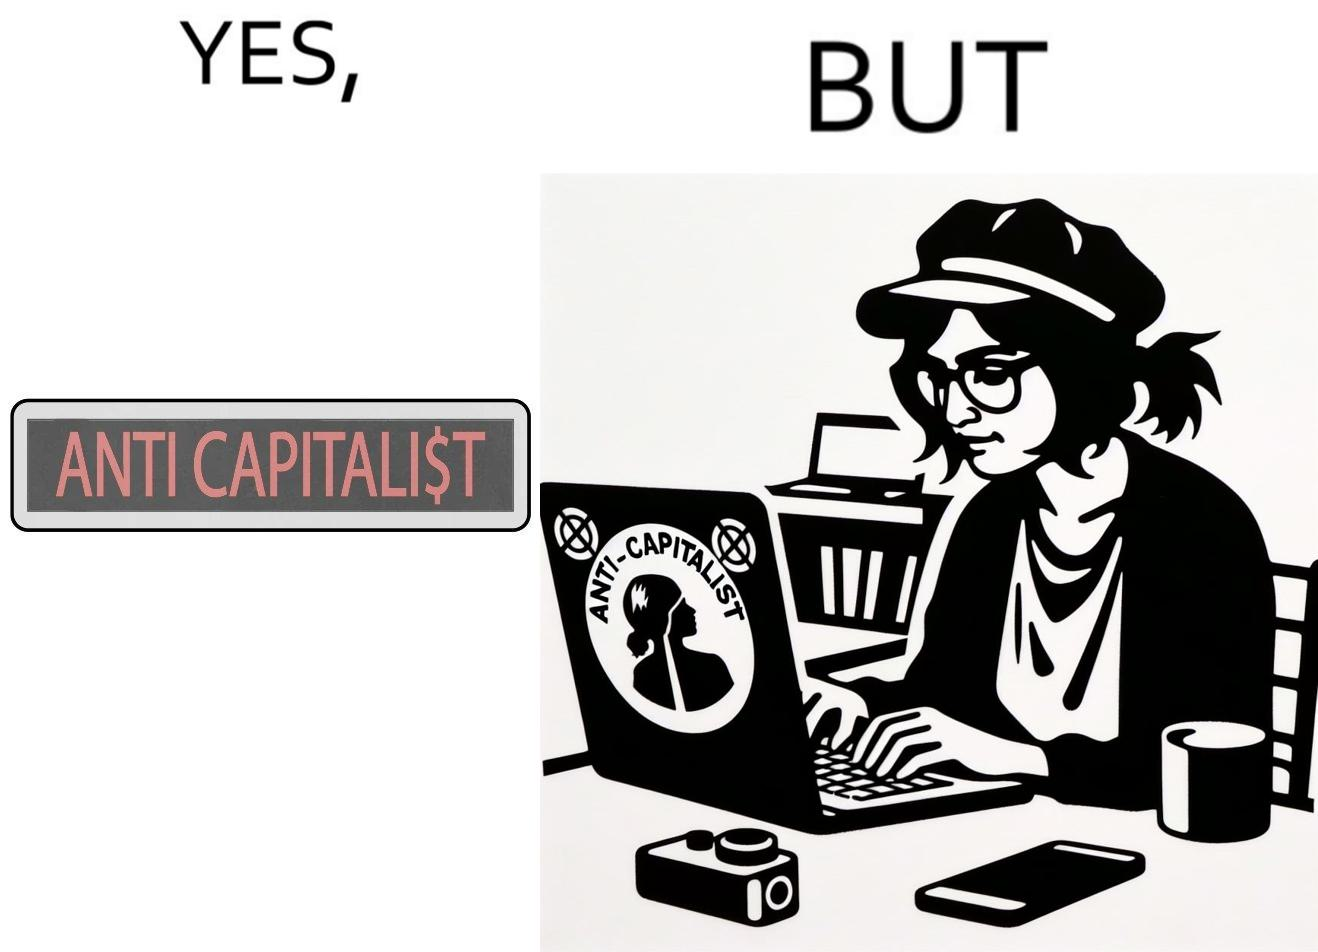Explain the humor or irony in this image. The overall image is ironical because the people who claim to be anticapitalist are the ones with a lot of capital as shown here. While the woman supports anticapitalism as shown by the sticker on the back of her laptop, she has a phone, a camera and a laptop all of which require money. 